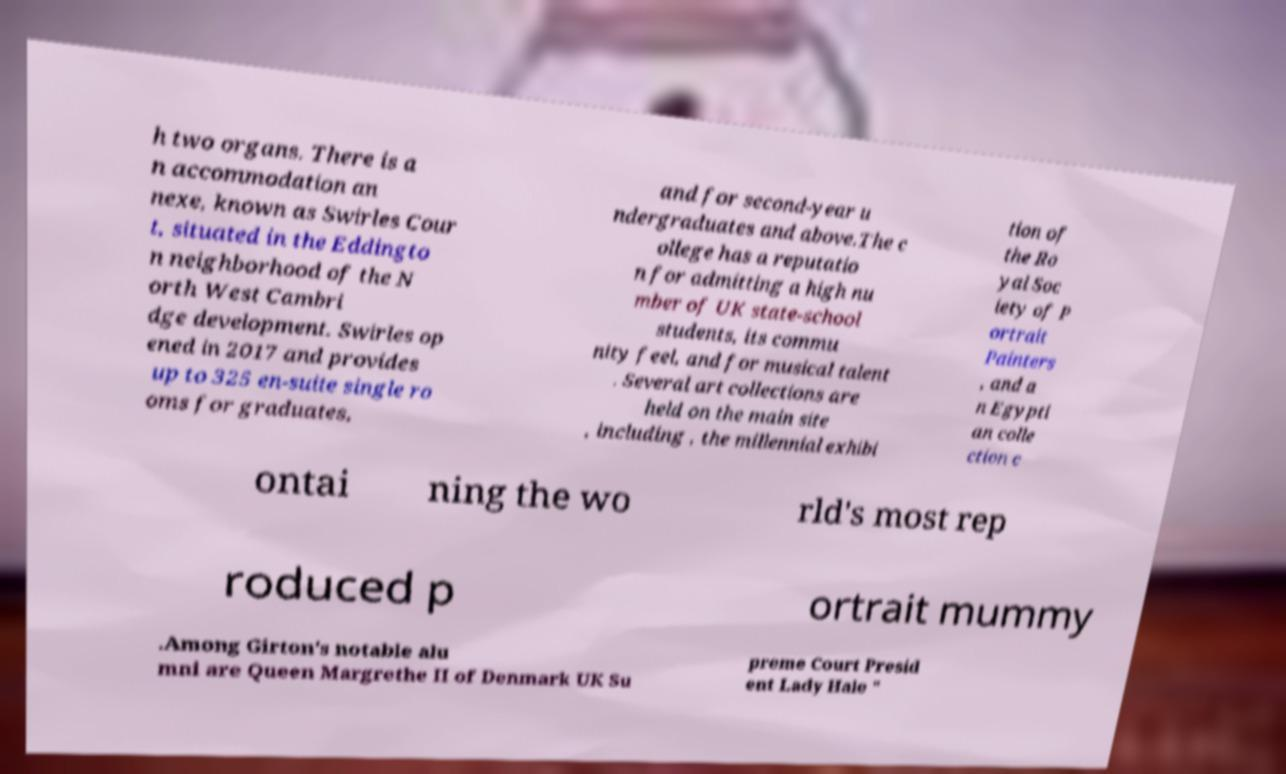Please identify and transcribe the text found in this image. h two organs. There is a n accommodation an nexe, known as Swirles Cour t, situated in the Eddingto n neighborhood of the N orth West Cambri dge development. Swirles op ened in 2017 and provides up to 325 en-suite single ro oms for graduates, and for second-year u ndergraduates and above.The c ollege has a reputatio n for admitting a high nu mber of UK state-school students, its commu nity feel, and for musical talent . Several art collections are held on the main site , including , the millennial exhibi tion of the Ro yal Soc iety of P ortrait Painters , and a n Egypti an colle ction c ontai ning the wo rld's most rep roduced p ortrait mummy .Among Girton's notable alu mni are Queen Margrethe II of Denmark UK Su preme Court Presid ent Lady Hale " 